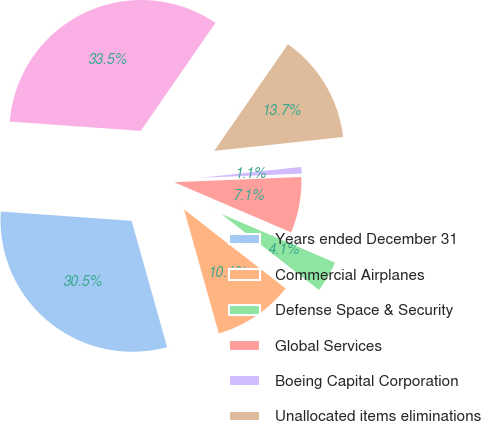<chart> <loc_0><loc_0><loc_500><loc_500><pie_chart><fcel>Years ended December 31<fcel>Commercial Airplanes<fcel>Defense Space & Security<fcel>Global Services<fcel>Boeing Capital Corporation<fcel>Unallocated items eliminations<fcel>Total<nl><fcel>30.48%<fcel>10.12%<fcel>4.08%<fcel>7.1%<fcel>1.06%<fcel>13.66%<fcel>33.5%<nl></chart> 